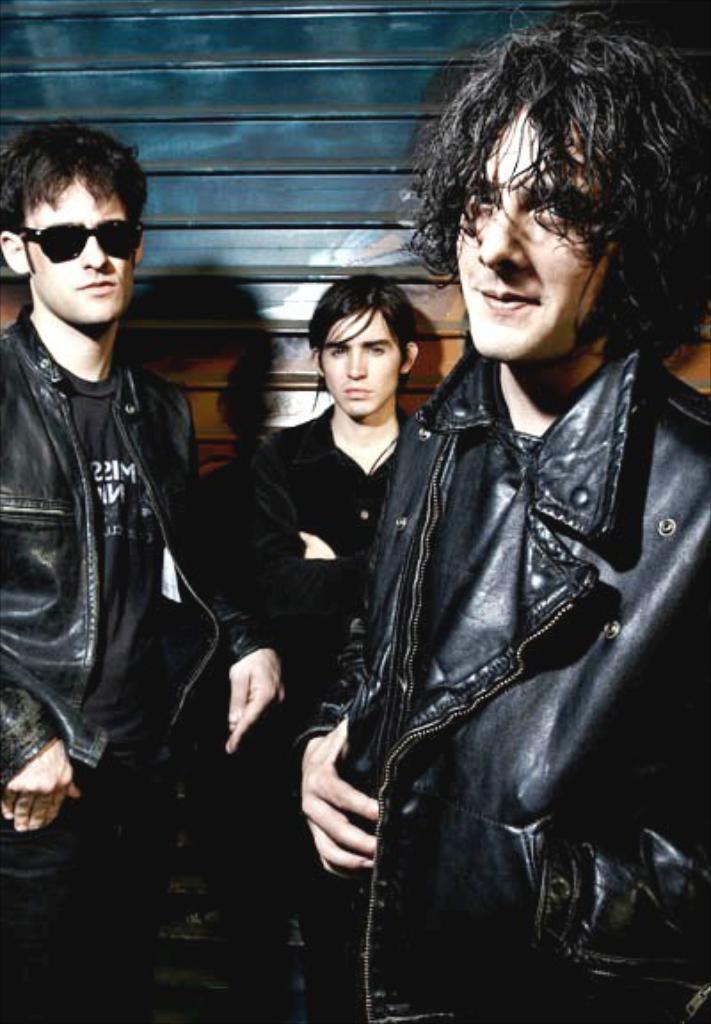Describe this image in one or two sentences. In the picture I can see three men are standing and wearing dark color clothes. In the background I can see a wall. 